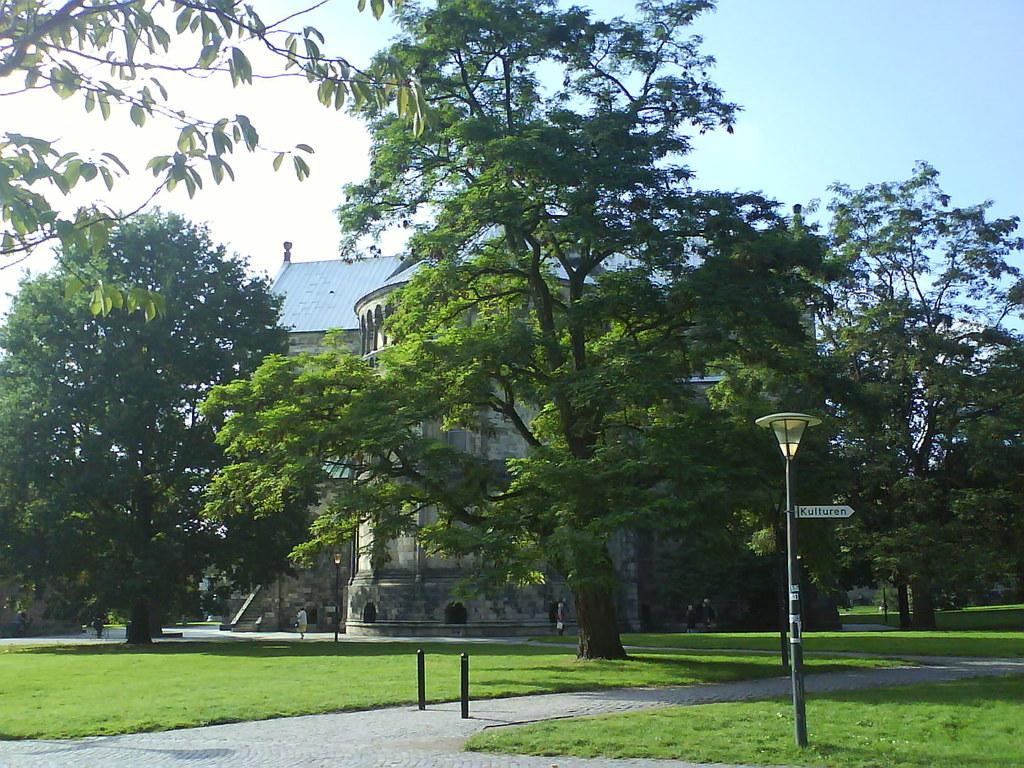What type of structure can be seen in the image? There is a building in the image. What type of lighting is present in the image? Street lights are present in the image. What type of poles are visible in the image? Street poles are visible in the image. What type of signage is present in the image? There is a sign board in the image. What type of barriers are present in the image? Barriers are present in the image. What type of surface is visible in the image? The ground is visible in the image. What type of vegetation is present in the image? Trees are present in the image. What type of natural element is visible in the image? The sky is visible in the image. Can you see the fingerprints on the building in the image? There is no mention of fingerprints or any indication that they would be visible on the building in the image. 